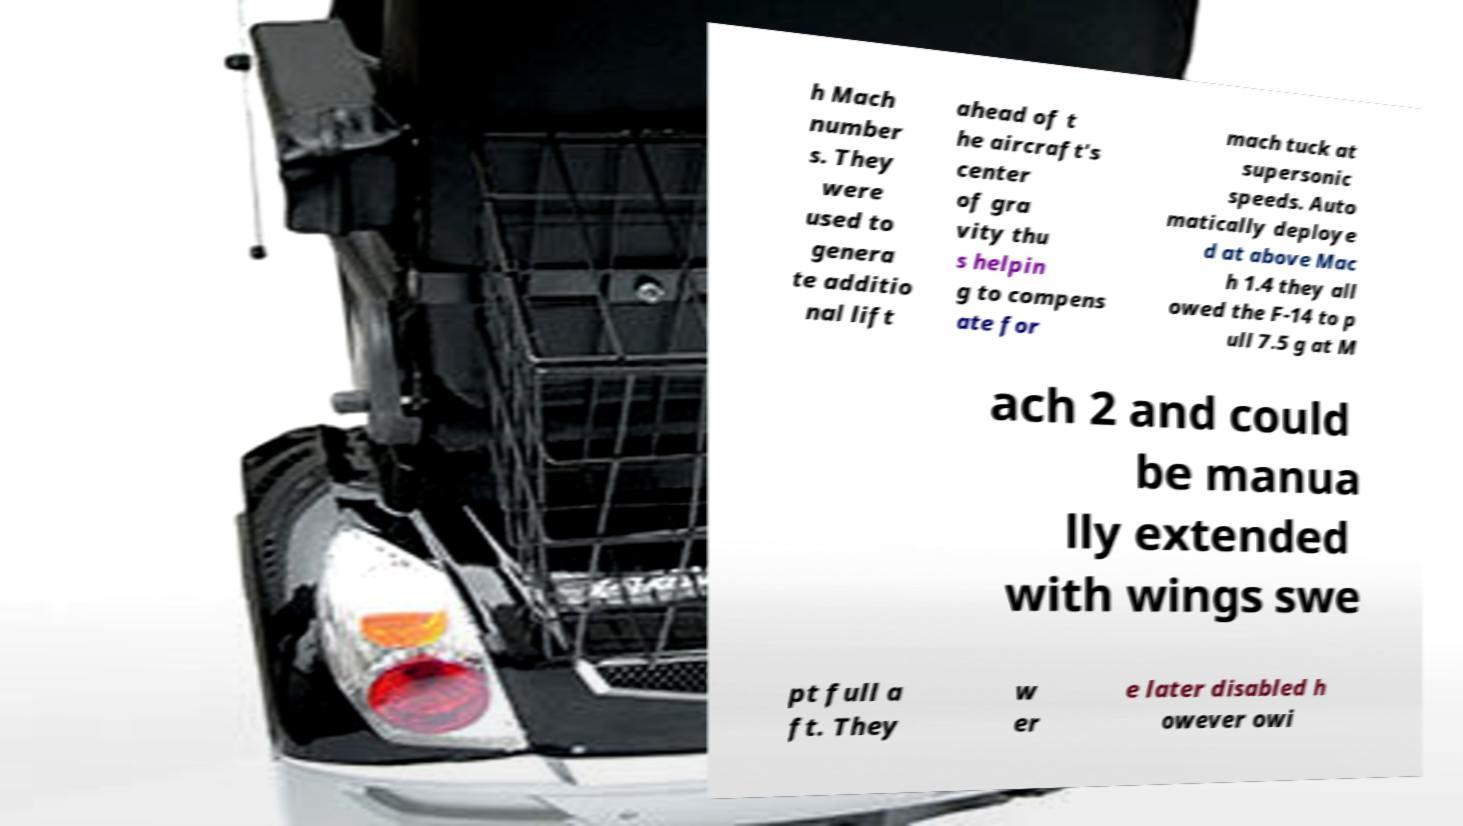Please read and relay the text visible in this image. What does it say? h Mach number s. They were used to genera te additio nal lift ahead of t he aircraft's center of gra vity thu s helpin g to compens ate for mach tuck at supersonic speeds. Auto matically deploye d at above Mac h 1.4 they all owed the F-14 to p ull 7.5 g at M ach 2 and could be manua lly extended with wings swe pt full a ft. They w er e later disabled h owever owi 